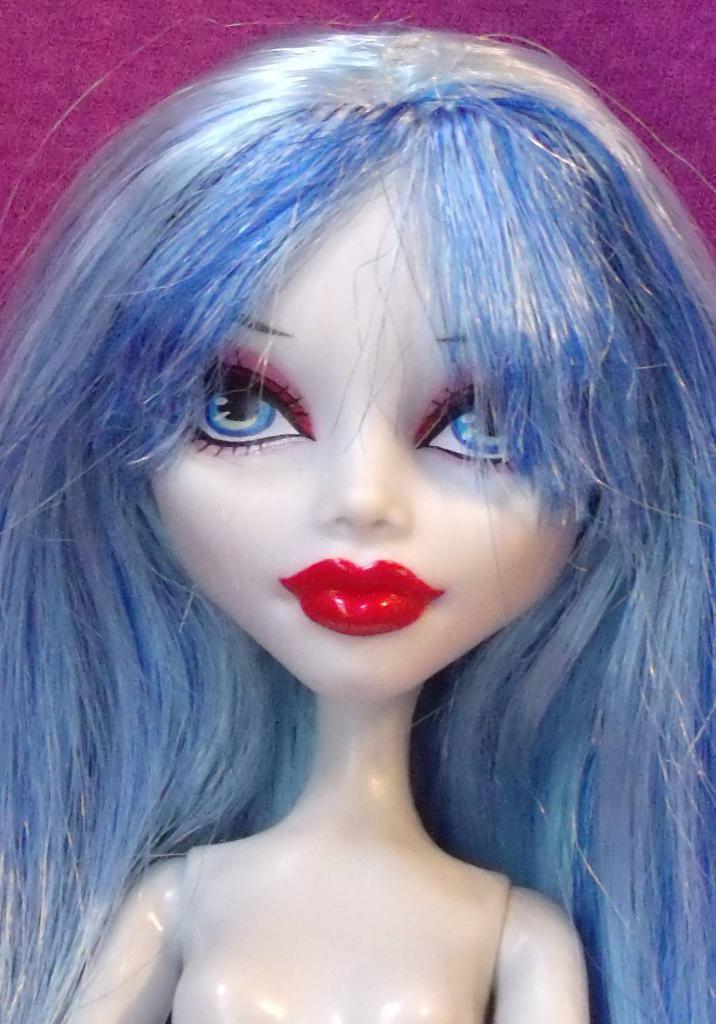How would you summarize this image in a sentence or two? In the center of the image a barbie doll is there. 